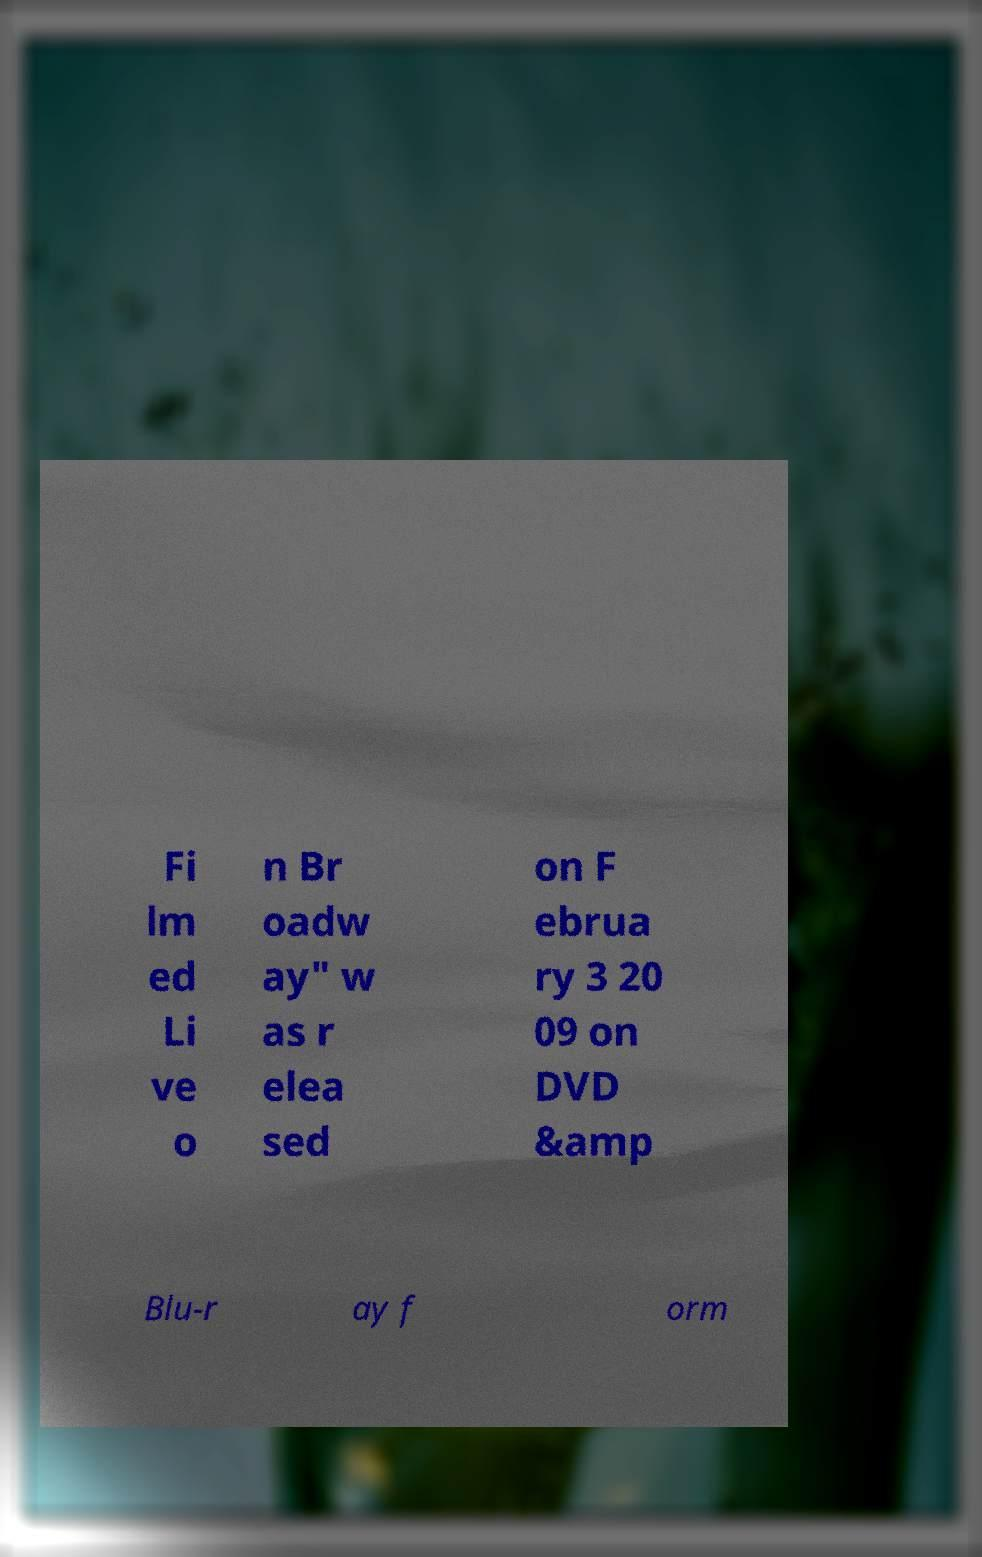Can you accurately transcribe the text from the provided image for me? Fi lm ed Li ve o n Br oadw ay" w as r elea sed on F ebrua ry 3 20 09 on DVD &amp Blu-r ay f orm 